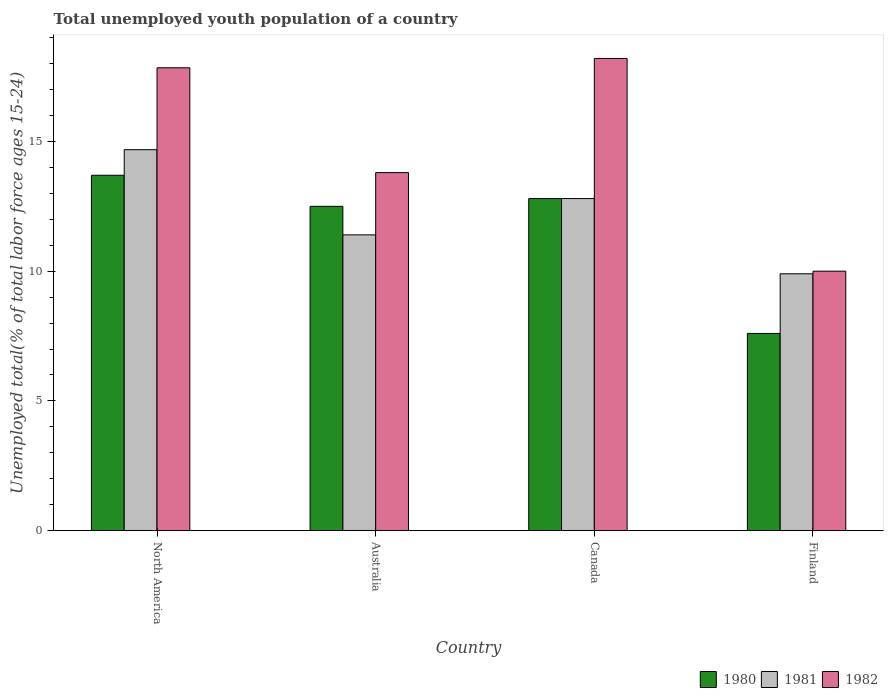How many different coloured bars are there?
Ensure brevity in your answer.  3. What is the label of the 2nd group of bars from the left?
Offer a terse response. Australia. What is the percentage of total unemployed youth population of a country in 1982 in Canada?
Give a very brief answer. 18.2. Across all countries, what is the maximum percentage of total unemployed youth population of a country in 1981?
Your response must be concise. 14.68. What is the total percentage of total unemployed youth population of a country in 1980 in the graph?
Give a very brief answer. 46.6. What is the difference between the percentage of total unemployed youth population of a country in 1982 in Canada and that in Finland?
Keep it short and to the point. 8.2. What is the difference between the percentage of total unemployed youth population of a country in 1982 in Australia and the percentage of total unemployed youth population of a country in 1980 in Canada?
Provide a short and direct response. 1. What is the average percentage of total unemployed youth population of a country in 1981 per country?
Provide a succinct answer. 12.2. What is the difference between the percentage of total unemployed youth population of a country of/in 1981 and percentage of total unemployed youth population of a country of/in 1980 in Finland?
Offer a terse response. 2.3. In how many countries, is the percentage of total unemployed youth population of a country in 1981 greater than 17 %?
Give a very brief answer. 0. What is the ratio of the percentage of total unemployed youth population of a country in 1981 in Finland to that in North America?
Your answer should be compact. 0.67. Is the percentage of total unemployed youth population of a country in 1981 in Australia less than that in Canada?
Offer a terse response. Yes. What is the difference between the highest and the second highest percentage of total unemployed youth population of a country in 1981?
Offer a very short reply. -1.4. What is the difference between the highest and the lowest percentage of total unemployed youth population of a country in 1981?
Provide a short and direct response. 4.78. Is the sum of the percentage of total unemployed youth population of a country in 1982 in Canada and Finland greater than the maximum percentage of total unemployed youth population of a country in 1980 across all countries?
Offer a very short reply. Yes. Are the values on the major ticks of Y-axis written in scientific E-notation?
Ensure brevity in your answer.  No. Does the graph contain grids?
Give a very brief answer. No. Where does the legend appear in the graph?
Keep it short and to the point. Bottom right. What is the title of the graph?
Your answer should be compact. Total unemployed youth population of a country. What is the label or title of the X-axis?
Your answer should be very brief. Country. What is the label or title of the Y-axis?
Provide a short and direct response. Unemployed total(% of total labor force ages 15-24). What is the Unemployed total(% of total labor force ages 15-24) in 1980 in North America?
Provide a short and direct response. 13.7. What is the Unemployed total(% of total labor force ages 15-24) of 1981 in North America?
Your response must be concise. 14.68. What is the Unemployed total(% of total labor force ages 15-24) in 1982 in North America?
Offer a very short reply. 17.84. What is the Unemployed total(% of total labor force ages 15-24) in 1981 in Australia?
Your response must be concise. 11.4. What is the Unemployed total(% of total labor force ages 15-24) of 1982 in Australia?
Provide a short and direct response. 13.8. What is the Unemployed total(% of total labor force ages 15-24) in 1980 in Canada?
Keep it short and to the point. 12.8. What is the Unemployed total(% of total labor force ages 15-24) in 1981 in Canada?
Offer a terse response. 12.8. What is the Unemployed total(% of total labor force ages 15-24) in 1982 in Canada?
Provide a short and direct response. 18.2. What is the Unemployed total(% of total labor force ages 15-24) of 1980 in Finland?
Provide a succinct answer. 7.6. What is the Unemployed total(% of total labor force ages 15-24) in 1981 in Finland?
Your answer should be compact. 9.9. What is the Unemployed total(% of total labor force ages 15-24) of 1982 in Finland?
Your answer should be compact. 10. Across all countries, what is the maximum Unemployed total(% of total labor force ages 15-24) in 1980?
Give a very brief answer. 13.7. Across all countries, what is the maximum Unemployed total(% of total labor force ages 15-24) in 1981?
Keep it short and to the point. 14.68. Across all countries, what is the maximum Unemployed total(% of total labor force ages 15-24) of 1982?
Your response must be concise. 18.2. Across all countries, what is the minimum Unemployed total(% of total labor force ages 15-24) of 1980?
Provide a succinct answer. 7.6. Across all countries, what is the minimum Unemployed total(% of total labor force ages 15-24) in 1981?
Give a very brief answer. 9.9. Across all countries, what is the minimum Unemployed total(% of total labor force ages 15-24) of 1982?
Keep it short and to the point. 10. What is the total Unemployed total(% of total labor force ages 15-24) of 1980 in the graph?
Offer a very short reply. 46.6. What is the total Unemployed total(% of total labor force ages 15-24) of 1981 in the graph?
Ensure brevity in your answer.  48.78. What is the total Unemployed total(% of total labor force ages 15-24) in 1982 in the graph?
Provide a succinct answer. 59.84. What is the difference between the Unemployed total(% of total labor force ages 15-24) in 1980 in North America and that in Australia?
Your answer should be compact. 1.2. What is the difference between the Unemployed total(% of total labor force ages 15-24) in 1981 in North America and that in Australia?
Ensure brevity in your answer.  3.28. What is the difference between the Unemployed total(% of total labor force ages 15-24) of 1982 in North America and that in Australia?
Your answer should be very brief. 4.04. What is the difference between the Unemployed total(% of total labor force ages 15-24) in 1980 in North America and that in Canada?
Your response must be concise. 0.9. What is the difference between the Unemployed total(% of total labor force ages 15-24) in 1981 in North America and that in Canada?
Ensure brevity in your answer.  1.88. What is the difference between the Unemployed total(% of total labor force ages 15-24) in 1982 in North America and that in Canada?
Keep it short and to the point. -0.36. What is the difference between the Unemployed total(% of total labor force ages 15-24) of 1980 in North America and that in Finland?
Make the answer very short. 6.1. What is the difference between the Unemployed total(% of total labor force ages 15-24) in 1981 in North America and that in Finland?
Your answer should be very brief. 4.78. What is the difference between the Unemployed total(% of total labor force ages 15-24) in 1982 in North America and that in Finland?
Provide a short and direct response. 7.84. What is the difference between the Unemployed total(% of total labor force ages 15-24) in 1982 in Australia and that in Canada?
Offer a very short reply. -4.4. What is the difference between the Unemployed total(% of total labor force ages 15-24) in 1980 in Australia and that in Finland?
Offer a terse response. 4.9. What is the difference between the Unemployed total(% of total labor force ages 15-24) of 1981 in Australia and that in Finland?
Your answer should be compact. 1.5. What is the difference between the Unemployed total(% of total labor force ages 15-24) in 1982 in Australia and that in Finland?
Your answer should be compact. 3.8. What is the difference between the Unemployed total(% of total labor force ages 15-24) in 1980 in North America and the Unemployed total(% of total labor force ages 15-24) in 1981 in Australia?
Ensure brevity in your answer.  2.3. What is the difference between the Unemployed total(% of total labor force ages 15-24) of 1980 in North America and the Unemployed total(% of total labor force ages 15-24) of 1982 in Australia?
Your answer should be very brief. -0.1. What is the difference between the Unemployed total(% of total labor force ages 15-24) in 1981 in North America and the Unemployed total(% of total labor force ages 15-24) in 1982 in Australia?
Your answer should be very brief. 0.88. What is the difference between the Unemployed total(% of total labor force ages 15-24) of 1980 in North America and the Unemployed total(% of total labor force ages 15-24) of 1981 in Canada?
Provide a short and direct response. 0.9. What is the difference between the Unemployed total(% of total labor force ages 15-24) of 1980 in North America and the Unemployed total(% of total labor force ages 15-24) of 1982 in Canada?
Provide a succinct answer. -4.5. What is the difference between the Unemployed total(% of total labor force ages 15-24) in 1981 in North America and the Unemployed total(% of total labor force ages 15-24) in 1982 in Canada?
Provide a succinct answer. -3.52. What is the difference between the Unemployed total(% of total labor force ages 15-24) of 1980 in North America and the Unemployed total(% of total labor force ages 15-24) of 1981 in Finland?
Your answer should be compact. 3.8. What is the difference between the Unemployed total(% of total labor force ages 15-24) in 1980 in North America and the Unemployed total(% of total labor force ages 15-24) in 1982 in Finland?
Provide a succinct answer. 3.7. What is the difference between the Unemployed total(% of total labor force ages 15-24) in 1981 in North America and the Unemployed total(% of total labor force ages 15-24) in 1982 in Finland?
Make the answer very short. 4.68. What is the difference between the Unemployed total(% of total labor force ages 15-24) of 1980 in Australia and the Unemployed total(% of total labor force ages 15-24) of 1981 in Canada?
Ensure brevity in your answer.  -0.3. What is the difference between the Unemployed total(% of total labor force ages 15-24) in 1980 in Australia and the Unemployed total(% of total labor force ages 15-24) in 1982 in Canada?
Give a very brief answer. -5.7. What is the difference between the Unemployed total(% of total labor force ages 15-24) in 1981 in Australia and the Unemployed total(% of total labor force ages 15-24) in 1982 in Canada?
Provide a succinct answer. -6.8. What is the difference between the Unemployed total(% of total labor force ages 15-24) in 1980 in Australia and the Unemployed total(% of total labor force ages 15-24) in 1981 in Finland?
Make the answer very short. 2.6. What is the difference between the Unemployed total(% of total labor force ages 15-24) in 1980 in Australia and the Unemployed total(% of total labor force ages 15-24) in 1982 in Finland?
Provide a short and direct response. 2.5. What is the difference between the Unemployed total(% of total labor force ages 15-24) in 1980 in Canada and the Unemployed total(% of total labor force ages 15-24) in 1981 in Finland?
Your answer should be compact. 2.9. What is the difference between the Unemployed total(% of total labor force ages 15-24) of 1980 in Canada and the Unemployed total(% of total labor force ages 15-24) of 1982 in Finland?
Your answer should be compact. 2.8. What is the average Unemployed total(% of total labor force ages 15-24) of 1980 per country?
Your answer should be very brief. 11.65. What is the average Unemployed total(% of total labor force ages 15-24) in 1981 per country?
Make the answer very short. 12.2. What is the average Unemployed total(% of total labor force ages 15-24) in 1982 per country?
Your response must be concise. 14.96. What is the difference between the Unemployed total(% of total labor force ages 15-24) of 1980 and Unemployed total(% of total labor force ages 15-24) of 1981 in North America?
Give a very brief answer. -0.99. What is the difference between the Unemployed total(% of total labor force ages 15-24) in 1980 and Unemployed total(% of total labor force ages 15-24) in 1982 in North America?
Give a very brief answer. -4.14. What is the difference between the Unemployed total(% of total labor force ages 15-24) in 1981 and Unemployed total(% of total labor force ages 15-24) in 1982 in North America?
Keep it short and to the point. -3.16. What is the difference between the Unemployed total(% of total labor force ages 15-24) in 1980 and Unemployed total(% of total labor force ages 15-24) in 1981 in Australia?
Provide a succinct answer. 1.1. What is the difference between the Unemployed total(% of total labor force ages 15-24) in 1980 and Unemployed total(% of total labor force ages 15-24) in 1981 in Canada?
Give a very brief answer. 0. What is the difference between the Unemployed total(% of total labor force ages 15-24) in 1980 and Unemployed total(% of total labor force ages 15-24) in 1982 in Canada?
Provide a short and direct response. -5.4. What is the difference between the Unemployed total(% of total labor force ages 15-24) in 1980 and Unemployed total(% of total labor force ages 15-24) in 1981 in Finland?
Your answer should be compact. -2.3. What is the difference between the Unemployed total(% of total labor force ages 15-24) of 1981 and Unemployed total(% of total labor force ages 15-24) of 1982 in Finland?
Give a very brief answer. -0.1. What is the ratio of the Unemployed total(% of total labor force ages 15-24) of 1980 in North America to that in Australia?
Offer a terse response. 1.1. What is the ratio of the Unemployed total(% of total labor force ages 15-24) of 1981 in North America to that in Australia?
Make the answer very short. 1.29. What is the ratio of the Unemployed total(% of total labor force ages 15-24) of 1982 in North America to that in Australia?
Your answer should be very brief. 1.29. What is the ratio of the Unemployed total(% of total labor force ages 15-24) of 1980 in North America to that in Canada?
Your answer should be very brief. 1.07. What is the ratio of the Unemployed total(% of total labor force ages 15-24) of 1981 in North America to that in Canada?
Ensure brevity in your answer.  1.15. What is the ratio of the Unemployed total(% of total labor force ages 15-24) in 1982 in North America to that in Canada?
Ensure brevity in your answer.  0.98. What is the ratio of the Unemployed total(% of total labor force ages 15-24) of 1980 in North America to that in Finland?
Keep it short and to the point. 1.8. What is the ratio of the Unemployed total(% of total labor force ages 15-24) in 1981 in North America to that in Finland?
Offer a very short reply. 1.48. What is the ratio of the Unemployed total(% of total labor force ages 15-24) in 1982 in North America to that in Finland?
Your response must be concise. 1.78. What is the ratio of the Unemployed total(% of total labor force ages 15-24) in 1980 in Australia to that in Canada?
Your response must be concise. 0.98. What is the ratio of the Unemployed total(% of total labor force ages 15-24) of 1981 in Australia to that in Canada?
Your answer should be compact. 0.89. What is the ratio of the Unemployed total(% of total labor force ages 15-24) in 1982 in Australia to that in Canada?
Your response must be concise. 0.76. What is the ratio of the Unemployed total(% of total labor force ages 15-24) in 1980 in Australia to that in Finland?
Offer a very short reply. 1.64. What is the ratio of the Unemployed total(% of total labor force ages 15-24) of 1981 in Australia to that in Finland?
Ensure brevity in your answer.  1.15. What is the ratio of the Unemployed total(% of total labor force ages 15-24) in 1982 in Australia to that in Finland?
Give a very brief answer. 1.38. What is the ratio of the Unemployed total(% of total labor force ages 15-24) in 1980 in Canada to that in Finland?
Your answer should be compact. 1.68. What is the ratio of the Unemployed total(% of total labor force ages 15-24) of 1981 in Canada to that in Finland?
Your answer should be very brief. 1.29. What is the ratio of the Unemployed total(% of total labor force ages 15-24) in 1982 in Canada to that in Finland?
Offer a terse response. 1.82. What is the difference between the highest and the second highest Unemployed total(% of total labor force ages 15-24) of 1980?
Keep it short and to the point. 0.9. What is the difference between the highest and the second highest Unemployed total(% of total labor force ages 15-24) of 1981?
Your answer should be compact. 1.88. What is the difference between the highest and the second highest Unemployed total(% of total labor force ages 15-24) of 1982?
Your answer should be very brief. 0.36. What is the difference between the highest and the lowest Unemployed total(% of total labor force ages 15-24) in 1980?
Your answer should be very brief. 6.1. What is the difference between the highest and the lowest Unemployed total(% of total labor force ages 15-24) of 1981?
Your response must be concise. 4.78. 